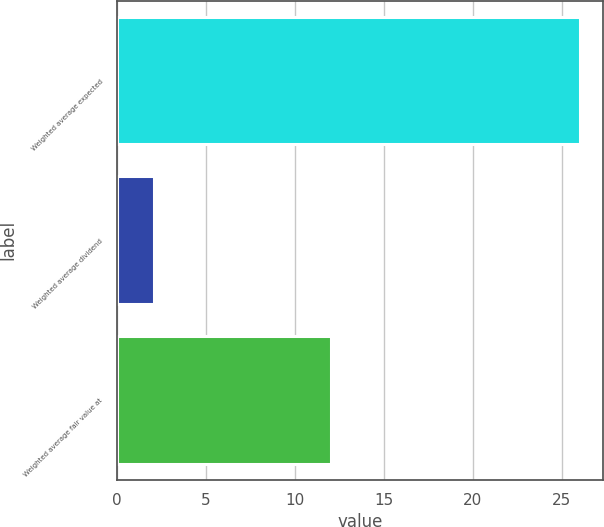Convert chart. <chart><loc_0><loc_0><loc_500><loc_500><bar_chart><fcel>Weighted average expected<fcel>Weighted average dividend<fcel>Weighted average fair value at<nl><fcel>26<fcel>2.1<fcel>12.01<nl></chart> 